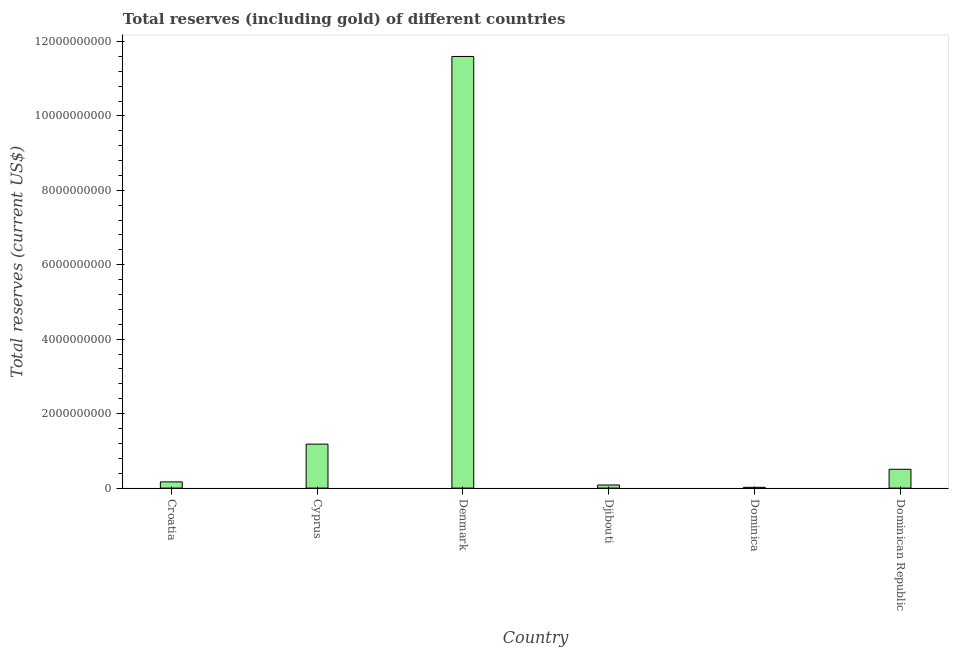Does the graph contain any zero values?
Offer a terse response. No. What is the title of the graph?
Offer a terse response. Total reserves (including gold) of different countries. What is the label or title of the X-axis?
Your answer should be very brief. Country. What is the label or title of the Y-axis?
Your answer should be compact. Total reserves (current US$). What is the total reserves (including gold) in Denmark?
Provide a short and direct response. 1.16e+1. Across all countries, what is the maximum total reserves (including gold)?
Provide a short and direct response. 1.16e+1. Across all countries, what is the minimum total reserves (including gold)?
Offer a very short reply. 2.04e+07. In which country was the total reserves (including gold) minimum?
Your answer should be compact. Dominica. What is the sum of the total reserves (including gold)?
Offer a very short reply. 1.36e+1. What is the difference between the total reserves (including gold) in Cyprus and Djibouti?
Your answer should be compact. 1.10e+09. What is the average total reserves (including gold) per country?
Provide a succinct answer. 2.26e+09. What is the median total reserves (including gold)?
Give a very brief answer. 3.36e+08. What is the ratio of the total reserves (including gold) in Cyprus to that in Dominican Republic?
Offer a terse response. 2.33. Is the total reserves (including gold) in Croatia less than that in Dominican Republic?
Give a very brief answer. Yes. What is the difference between the highest and the second highest total reserves (including gold)?
Your response must be concise. 1.04e+1. What is the difference between the highest and the lowest total reserves (including gold)?
Provide a succinct answer. 1.16e+1. How many bars are there?
Make the answer very short. 6. What is the difference between two consecutive major ticks on the Y-axis?
Offer a terse response. 2.00e+09. What is the Total reserves (current US$) of Croatia?
Offer a very short reply. 1.67e+08. What is the Total reserves (current US$) in Cyprus?
Your answer should be compact. 1.18e+09. What is the Total reserves (current US$) in Denmark?
Make the answer very short. 1.16e+1. What is the Total reserves (current US$) in Djibouti?
Your answer should be very brief. 8.34e+07. What is the Total reserves (current US$) in Dominica?
Your answer should be very brief. 2.04e+07. What is the Total reserves (current US$) in Dominican Republic?
Your answer should be very brief. 5.06e+08. What is the difference between the Total reserves (current US$) in Croatia and Cyprus?
Ensure brevity in your answer.  -1.01e+09. What is the difference between the Total reserves (current US$) in Croatia and Denmark?
Your answer should be very brief. -1.14e+1. What is the difference between the Total reserves (current US$) in Croatia and Djibouti?
Provide a short and direct response. 8.34e+07. What is the difference between the Total reserves (current US$) in Croatia and Dominica?
Offer a very short reply. 1.46e+08. What is the difference between the Total reserves (current US$) in Croatia and Dominican Republic?
Make the answer very short. -3.39e+08. What is the difference between the Total reserves (current US$) in Cyprus and Denmark?
Offer a very short reply. -1.04e+1. What is the difference between the Total reserves (current US$) in Cyprus and Djibouti?
Make the answer very short. 1.10e+09. What is the difference between the Total reserves (current US$) in Cyprus and Dominica?
Your response must be concise. 1.16e+09. What is the difference between the Total reserves (current US$) in Cyprus and Dominican Republic?
Your response must be concise. 6.75e+08. What is the difference between the Total reserves (current US$) in Denmark and Djibouti?
Give a very brief answer. 1.15e+1. What is the difference between the Total reserves (current US$) in Denmark and Dominica?
Give a very brief answer. 1.16e+1. What is the difference between the Total reserves (current US$) in Denmark and Dominican Republic?
Make the answer very short. 1.11e+1. What is the difference between the Total reserves (current US$) in Djibouti and Dominica?
Your response must be concise. 6.30e+07. What is the difference between the Total reserves (current US$) in Djibouti and Dominican Republic?
Your response must be concise. -4.22e+08. What is the difference between the Total reserves (current US$) in Dominica and Dominican Republic?
Make the answer very short. -4.85e+08. What is the ratio of the Total reserves (current US$) in Croatia to that in Cyprus?
Ensure brevity in your answer.  0.14. What is the ratio of the Total reserves (current US$) in Croatia to that in Denmark?
Provide a succinct answer. 0.01. What is the ratio of the Total reserves (current US$) in Croatia to that in Djibouti?
Your answer should be very brief. 2. What is the ratio of the Total reserves (current US$) in Croatia to that in Dominica?
Keep it short and to the point. 8.17. What is the ratio of the Total reserves (current US$) in Croatia to that in Dominican Republic?
Offer a very short reply. 0.33. What is the ratio of the Total reserves (current US$) in Cyprus to that in Denmark?
Keep it short and to the point. 0.1. What is the ratio of the Total reserves (current US$) in Cyprus to that in Djibouti?
Your answer should be compact. 14.16. What is the ratio of the Total reserves (current US$) in Cyprus to that in Dominica?
Provide a succinct answer. 57.86. What is the ratio of the Total reserves (current US$) in Cyprus to that in Dominican Republic?
Provide a short and direct response. 2.33. What is the ratio of the Total reserves (current US$) in Denmark to that in Djibouti?
Offer a terse response. 139.05. What is the ratio of the Total reserves (current US$) in Denmark to that in Dominica?
Offer a terse response. 568.19. What is the ratio of the Total reserves (current US$) in Denmark to that in Dominican Republic?
Keep it short and to the point. 22.93. What is the ratio of the Total reserves (current US$) in Djibouti to that in Dominica?
Give a very brief answer. 4.09. What is the ratio of the Total reserves (current US$) in Djibouti to that in Dominican Republic?
Make the answer very short. 0.17. What is the ratio of the Total reserves (current US$) in Dominica to that in Dominican Republic?
Your response must be concise. 0.04. 